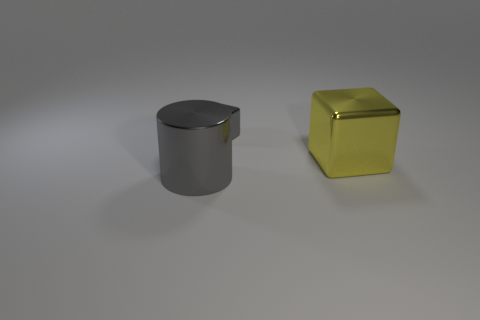Add 1 big yellow blocks. How many objects exist? 4 Subtract all cubes. How many objects are left? 1 Subtract 0 blue blocks. How many objects are left? 3 Subtract all tiny gray metallic blocks. Subtract all tiny cyan balls. How many objects are left? 2 Add 1 big metallic blocks. How many big metallic blocks are left? 2 Add 1 small gray blocks. How many small gray blocks exist? 2 